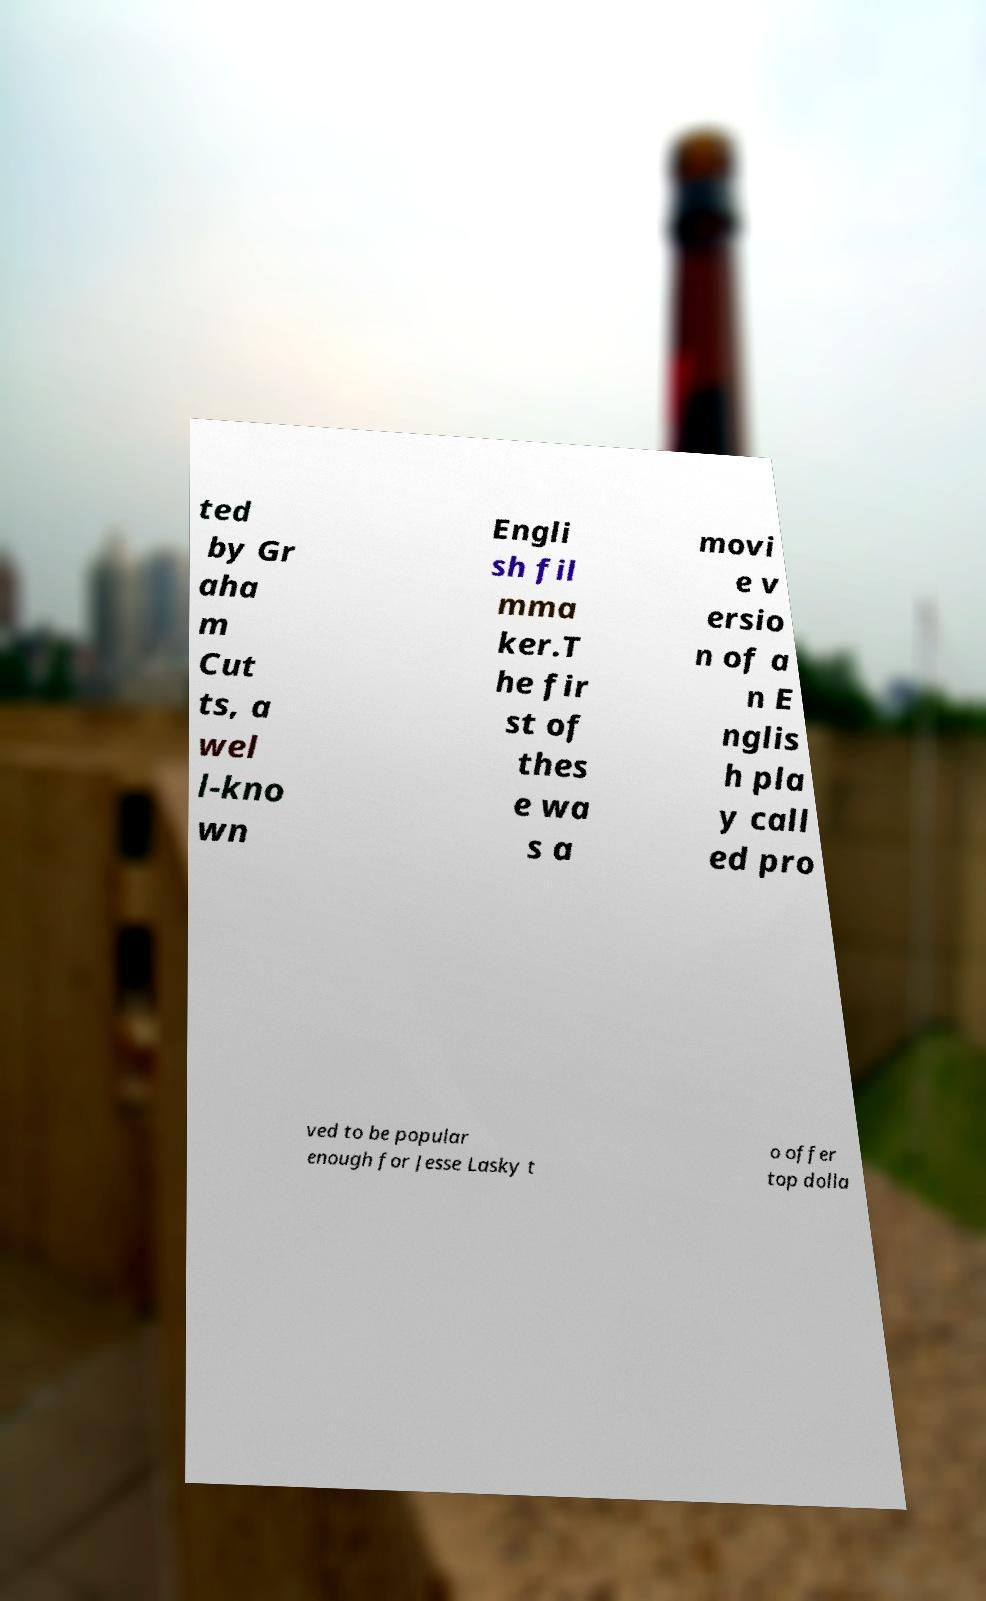Could you extract and type out the text from this image? ted by Gr aha m Cut ts, a wel l-kno wn Engli sh fil mma ker.T he fir st of thes e wa s a movi e v ersio n of a n E nglis h pla y call ed pro ved to be popular enough for Jesse Lasky t o offer top dolla 